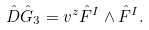<formula> <loc_0><loc_0><loc_500><loc_500>\hat { D } \hat { G } _ { 3 } = v ^ { z } \hat { F } ^ { I } \wedge \hat { F } ^ { I } .</formula> 